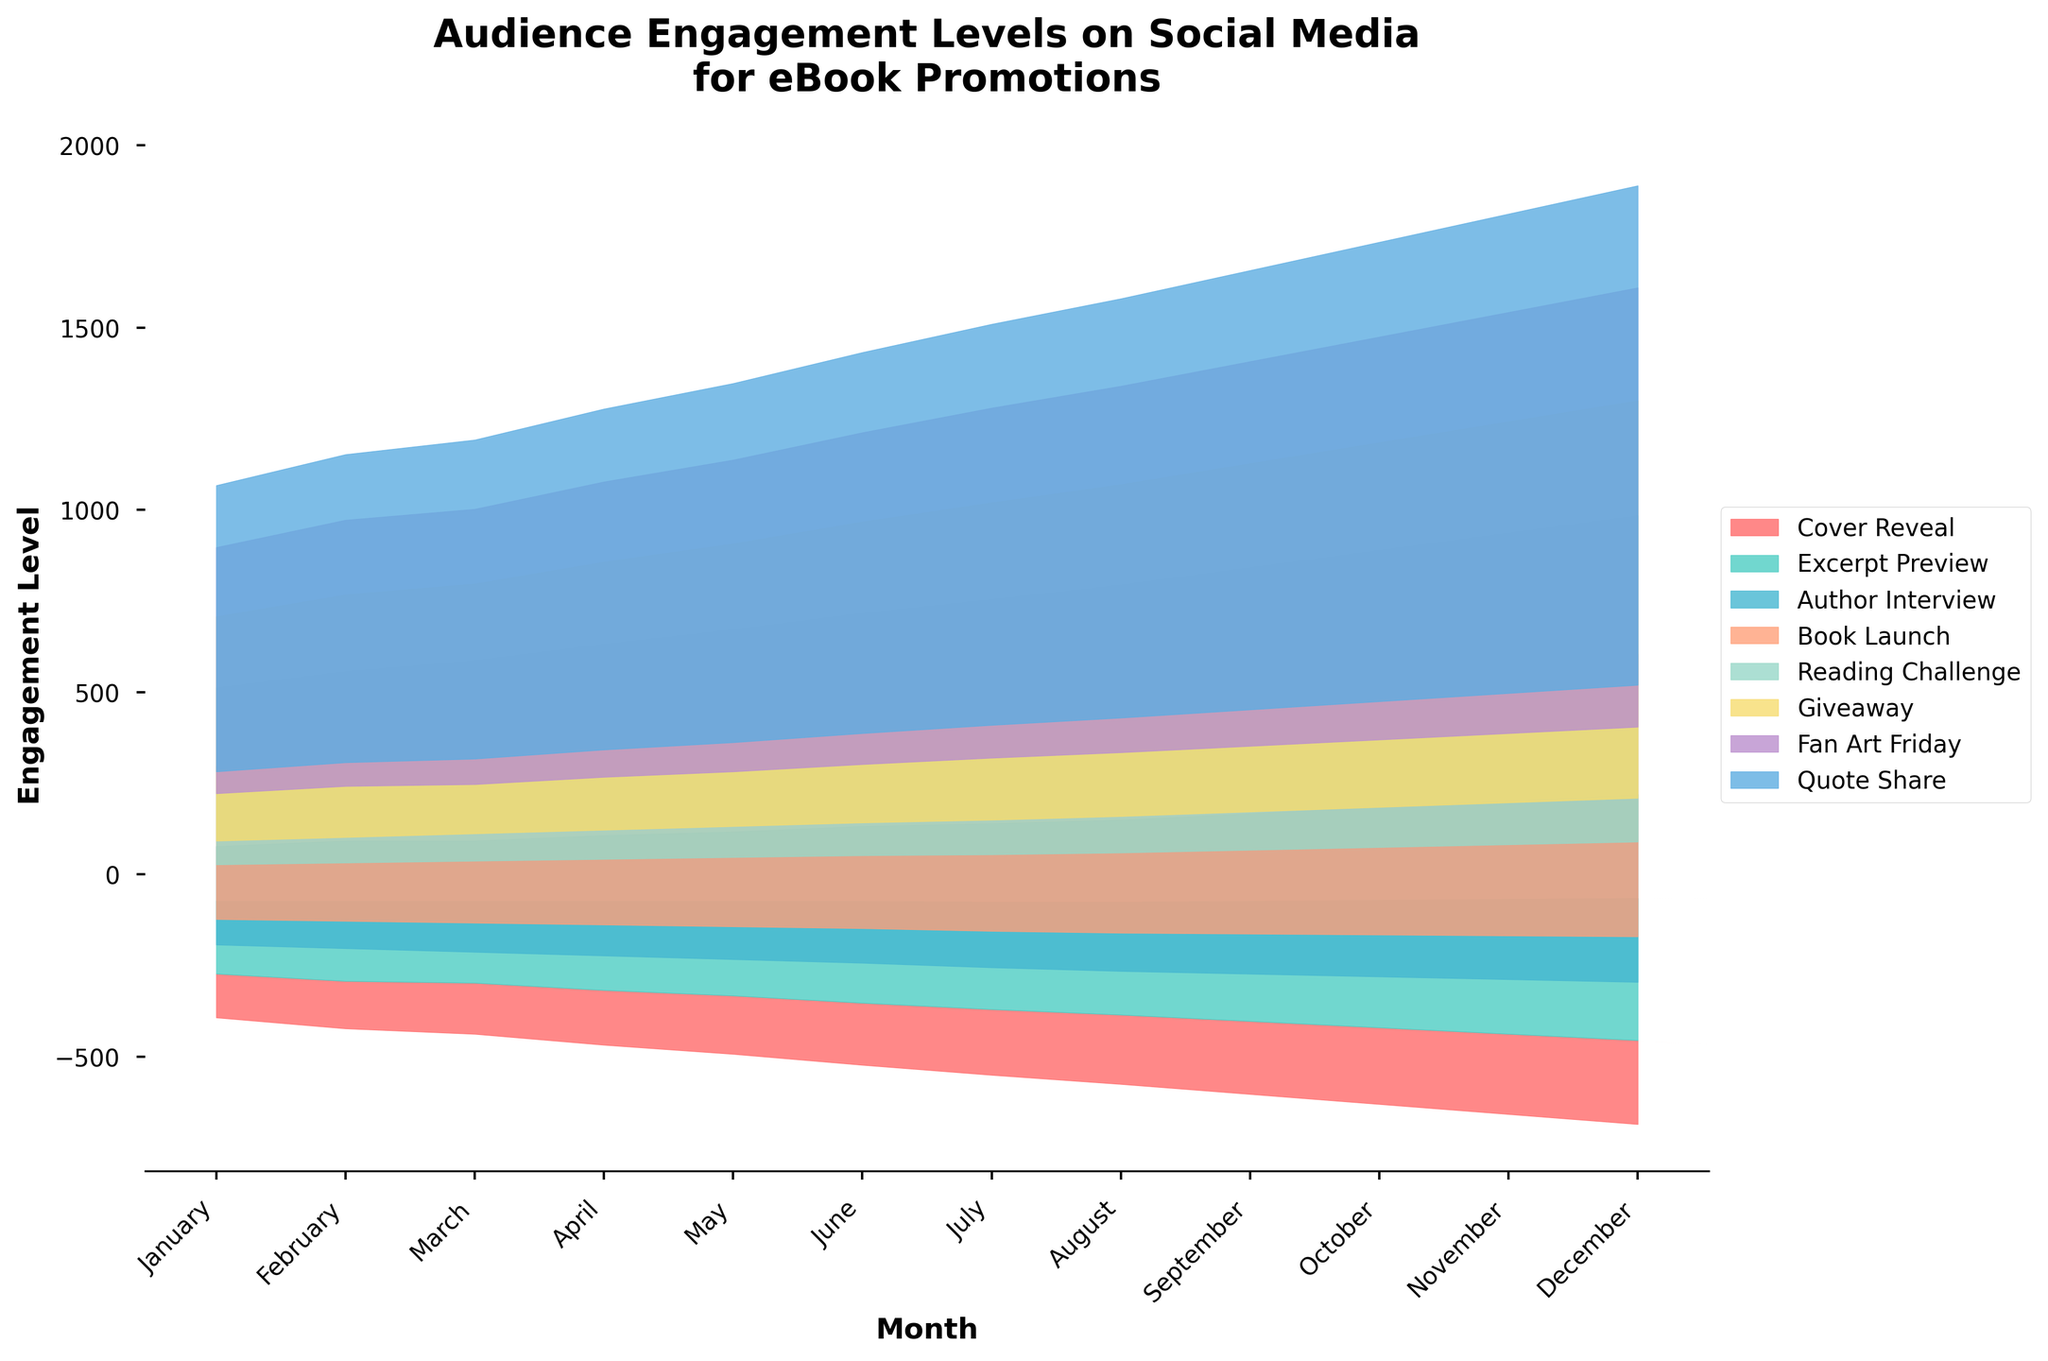What is the title of the figure? The title is mentioned at the top of the figure and typically describes what the graph is representing.
Answer: Audience Engagement Levels on Social Media for eBook Promotions What is the maximum engagement level for the 'Book Launch' post type? Locate the 'Book Launch' stream in the plot, and find the highest point of its corresponding area.
Answer: 260 Which post type shows the lowest engagement in January? Look at the January data, compare the heights of all post types, and identify the minimum one.
Answer: Fan Art Friday How does the engagement level for 'Cover Reveal' change from January to December? Notice the height changes for 'Cover Reveal' from January to December, starting at 120 and increasing to 230.
Answer: Increases by 110 Which month shows the highest total engagement across all post types? Sum the heights (engagement levels) for each month and compare to find the highest.
Answer: December How much did engagement for 'Giveaway' posts increase from January to December? Calculate the difference in the heights for 'Giveaway' between January (130) and December (195).
Answer: Increased by 65 Compare the engagement levels of 'Excerpt Preview' and 'Author Interview' in June. Which one has higher engagement? Locate June on the x-axis and compare the heights of 'Excerpt Preview' and 'Author Interview'.
Answer: Excerpt Preview What is the average engagement level for 'Reading Challenge' over the year? Sum the monthly engagement levels for 'Reading Challenge' and divide by 12. (65+70+75+80+85+90+95+100+105+110+115+120)/12
Answer: 90 Which post type consistently shows steady growth in engagement from January to December? Examine the trends for consistent upward movement without much fluctuation. Both 'Cover Reveal' and 'Book Launch' fit this description.
Answer: Cover Reveal and Book Launch In which month does 'Quote Share' engagement peak and what is the value? Identify the maximum height for 'Quote Share' and find the corresponding month.
Answer: December, 165 